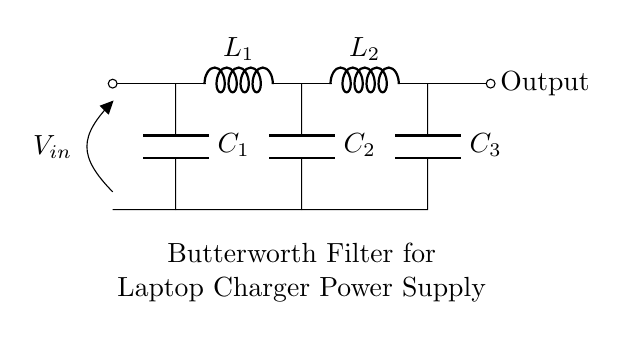What type of components are used in this filter? The components in this Butterworth filter include inductors and capacitors, specifically two inductors (L1 and L2) and three capacitors (C1, C2, and C3) shown in the diagram.
Answer: Inductors and capacitors What is the purpose of this Butterworth filter? The purpose of this Butterworth filter is to smooth the power supply output, reducing ripple voltage and ensuring a stable DC output suitable for a laptop charger.
Answer: Smoothing the power supply output How many capacitors are present in this circuit? There are three capacitors shown in the circuit diagram: C1, C2, and C3, each connected between different nodes of the circuit.
Answer: Three What is the configuration of the inductors in this filter? The inductors L1 and L2 are arranged in series, connecting sequentially between points leading to the output, which is typical for a Butterworth filter.
Answer: Series configuration Explain the order of this Butterworth filter. The order of a Butterworth filter is determined by the number of reactive components (L's and C's). In this circuit, we have two inductors and three capacitors, indicating a second-order filter. Higher order filters have sharper cutoff characteristics.
Answer: Second order What does V_in represent in this circuit? V_in represents the input voltage to the filter, which is indicated as the potential difference across the open connection at the beginning of the circuit, demonstrating the voltage source feeding the filter.
Answer: Input voltage 